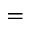<formula> <loc_0><loc_0><loc_500><loc_500>=</formula> 